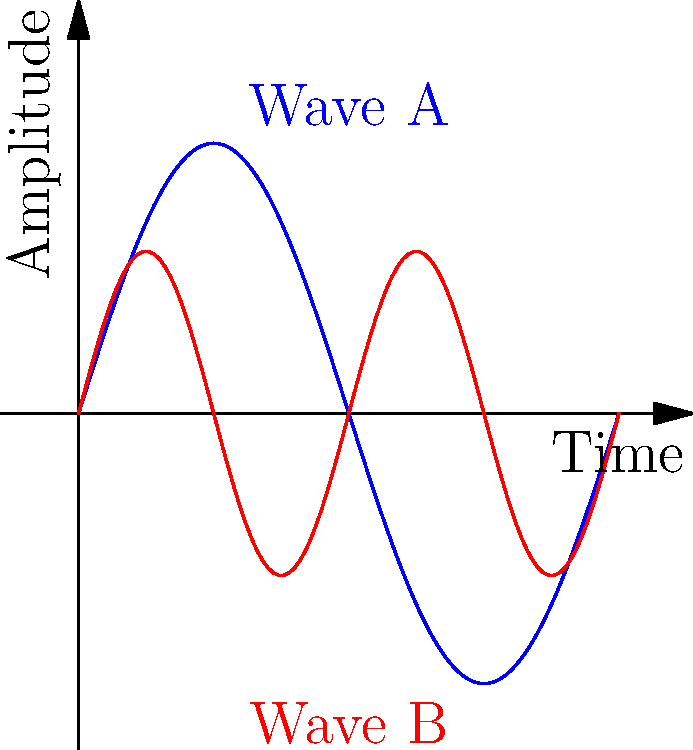Yo, aspiring MC! Imagine you're in the studio mixing tracks for your next hit, inspired by Kid Cudi's layered sound. You've got two sound waves represented above: Wave A (blue) and Wave B (red). If we treat these waves as vectors in a 1-second time frame, what's their dot product? Assume each wave is sampled at 1000 points over the 1-second interval. Let's break this down, fam:

1) The dot product of two vectors $\mathbf{a}$ and $\mathbf{b}$ is given by:

   $$\mathbf{a} \cdot \mathbf{b} = \sum_{i=1}^n a_i b_i$$

2) In our case, Wave A is represented by $f_1(x) = 0.5\sin(2\pi x)$ and Wave B by $f_2(x) = 0.3\sin(4\pi x)$.

3) We're sampling 1000 points, so let's set up our sum:

   $$\text{Dot Product} = \sum_{i=1}^{1000} f_1(\frac{i}{1000}) f_2(\frac{i}{1000})$$

4) Expanding this:

   $$\sum_{i=1}^{1000} [0.5\sin(2\pi \frac{i}{1000})] [0.3\sin(4\pi \frac{i}{1000})]$$

5) This simplifies to:

   $$0.15 \sum_{i=1}^{1000} \sin(2\pi \frac{i}{1000}) \sin(4\pi \frac{i}{1000})$$

6) Now, there's a trigonometric identity we can use:

   $$\sin A \sin B = \frac{1}{2}[\cos(A-B) - \cos(A+B)]$$

7) Applying this to our sum:

   $$0.075 \sum_{i=1}^{1000} [\cos(2\pi \frac{i}{1000} - 4\pi \frac{i}{1000}) - \cos(2\pi \frac{i}{1000} + 4\pi \frac{i}{1000})]$$

8) Simplifying:

   $$0.075 \sum_{i=1}^{1000} [\cos(-2\pi \frac{i}{1000}) - \cos(6\pi \frac{i}{1000})]$$

9) The sum of cosine over a full period is zero. Both terms here go through multiple full periods over the 1000 points.

Therefore, the dot product of these two waves over this interval is essentially zero.
Answer: 0 